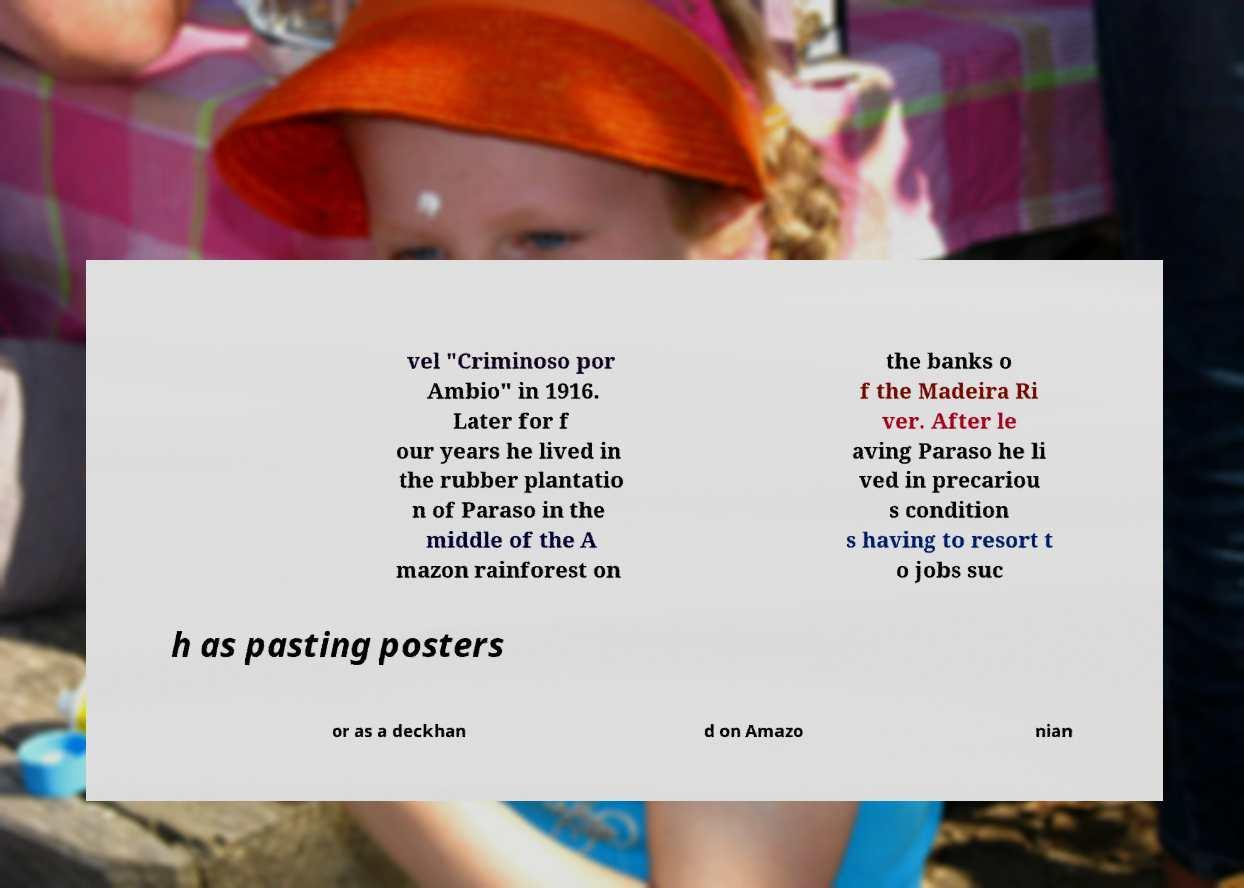For documentation purposes, I need the text within this image transcribed. Could you provide that? vel "Criminoso por Ambio" in 1916. Later for f our years he lived in the rubber plantatio n of Paraso in the middle of the A mazon rainforest on the banks o f the Madeira Ri ver. After le aving Paraso he li ved in precariou s condition s having to resort t o jobs suc h as pasting posters or as a deckhan d on Amazo nian 